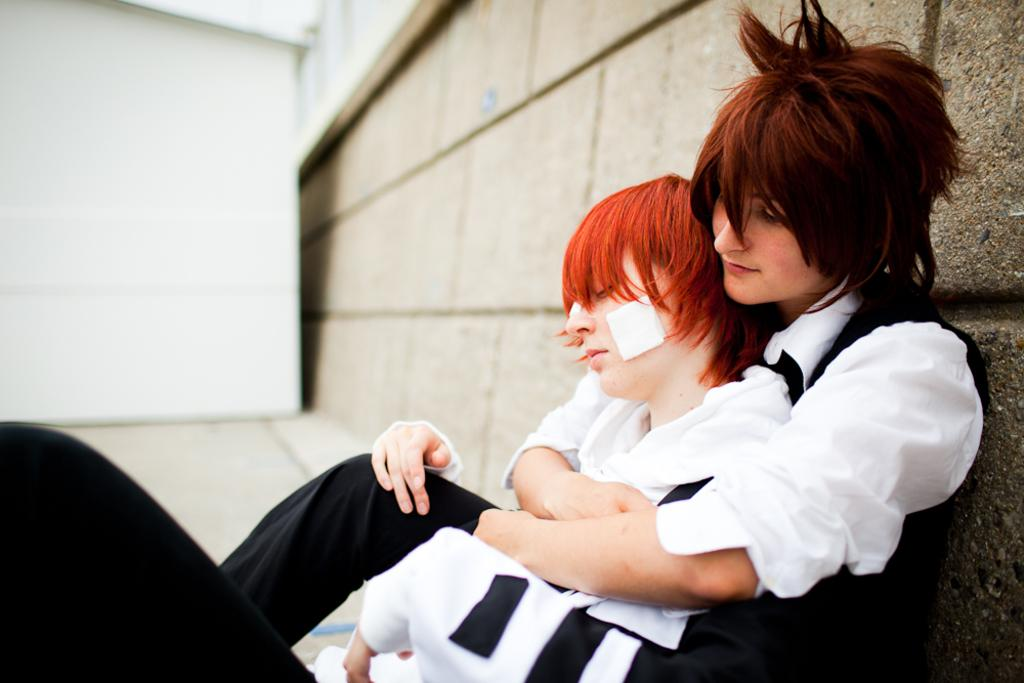What are the people in the image doing? The people in the image are sitting. What can be seen behind the people in the image? There is a wall visible in the background of the image. What is the surface that the people are sitting on? The floor is visible in the image. What religion is being practiced by the people in the image? There is no indication of any religious practice in the image. 